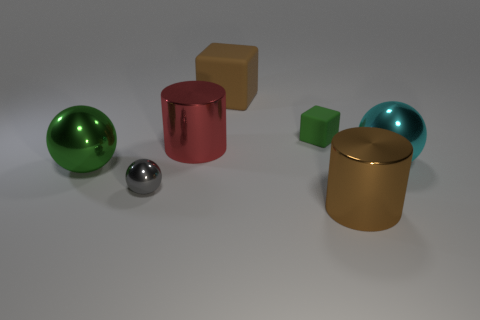Add 1 blocks. How many objects exist? 8 Subtract all balls. How many objects are left? 4 Add 6 tiny balls. How many tiny balls are left? 7 Add 1 rubber cubes. How many rubber cubes exist? 3 Subtract 0 gray cubes. How many objects are left? 7 Subtract all big cyan balls. Subtract all small rubber cubes. How many objects are left? 5 